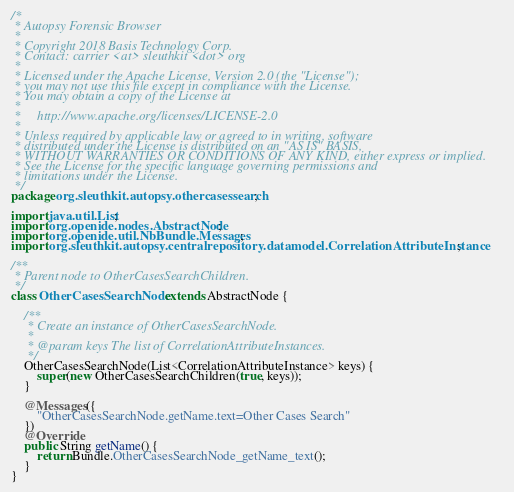Convert code to text. <code><loc_0><loc_0><loc_500><loc_500><_Java_>/*
 * Autopsy Forensic Browser
 *
 * Copyright 2018 Basis Technology Corp.
 * Contact: carrier <at> sleuthkit <dot> org
 *
 * Licensed under the Apache License, Version 2.0 (the "License");
 * you may not use this file except in compliance with the License.
 * You may obtain a copy of the License at
 *
 *     http://www.apache.org/licenses/LICENSE-2.0
 *
 * Unless required by applicable law or agreed to in writing, software
 * distributed under the License is distributed on an "AS IS" BASIS,
 * WITHOUT WARRANTIES OR CONDITIONS OF ANY KIND, either express or implied.
 * See the License for the specific language governing permissions and
 * limitations under the License.
 */
package org.sleuthkit.autopsy.othercasessearch;

import java.util.List;
import org.openide.nodes.AbstractNode;
import org.openide.util.NbBundle.Messages;
import org.sleuthkit.autopsy.centralrepository.datamodel.CorrelationAttributeInstance;

/**
 * Parent node to OtherCasesSearchChildren.
 */
class OtherCasesSearchNode extends AbstractNode {

    /**
     * Create an instance of OtherCasesSearchNode.
     * 
     * @param keys The list of CorrelationAttributeInstances.
     */
    OtherCasesSearchNode(List<CorrelationAttributeInstance> keys) {
        super(new OtherCasesSearchChildren(true, keys));
    }

    @Messages({
        "OtherCasesSearchNode.getName.text=Other Cases Search"
    })
    @Override
    public String getName() {
        return Bundle.OtherCasesSearchNode_getName_text();
    }
}
</code> 